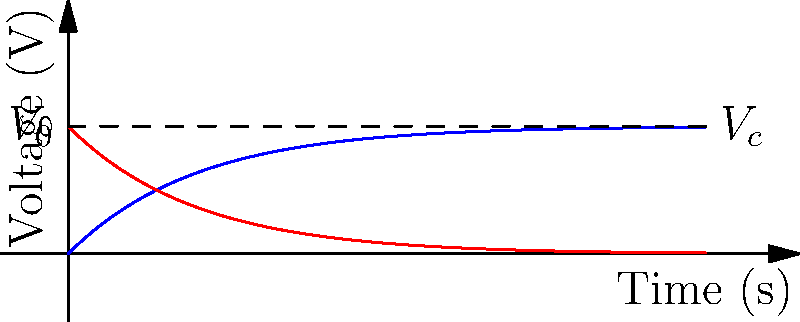In a Python programming context, explain how you would analyze and plot the charging and discharging curves of an RC circuit. The circuit has a resistance of 10 kΩ and a capacitance of 100 µF. What is the time constant $\tau$ of this circuit? To analyze and plot the RC circuit's charging and discharging curves in Python, we would follow these steps:

1. Import necessary libraries:
   ```python
   import numpy as np
   import matplotlib.pyplot as plt
   ```

2. Define circuit parameters:
   ```python
   R = 10e3  # 10 kΩ
   C = 100e-6  # 100 µF
   ```

3. Calculate the time constant:
   $\tau = RC$
   ```python
   tau = R * C
   ```

4. Create a time array:
   ```python
   t = np.linspace(0, 5*tau, 1000)
   ```

5. Define charging and discharging equations:
   Charging: $V_c(t) = V_0(1 - e^{-t/\tau})$
   Discharging: $V_c(t) = V_0e^{-t/\tau}$
   ```python
   V0 = 1  # Assuming a 1V source
   V_charging = V0 * (1 - np.exp(-t/tau))
   V_discharging = V0 * np.exp(-t/tau)
   ```

6. Plot the curves:
   ```python
   plt.figure(figsize=(10, 6))
   plt.plot(t, V_charging, 'b', label='Charging')
   plt.plot(t, V_discharging, 'r', label='Discharging')
   plt.xlabel('Time (s)')
   plt.ylabel('Voltage (V)')
   plt.title('RC Circuit Charging and Discharging Curves')
   plt.legend()
   plt.grid(True)
   plt.show()
   ```

The time constant $\tau$ is calculated as:
$\tau = RC = 10\,\text{k}\Omega \times 100\,\text{µF} = 10^4 \times 10^{-6} = 10^{-2}\,\text{s} = 10\,\text{ms}$
Answer: $\tau = 10\,\text{ms}$ 